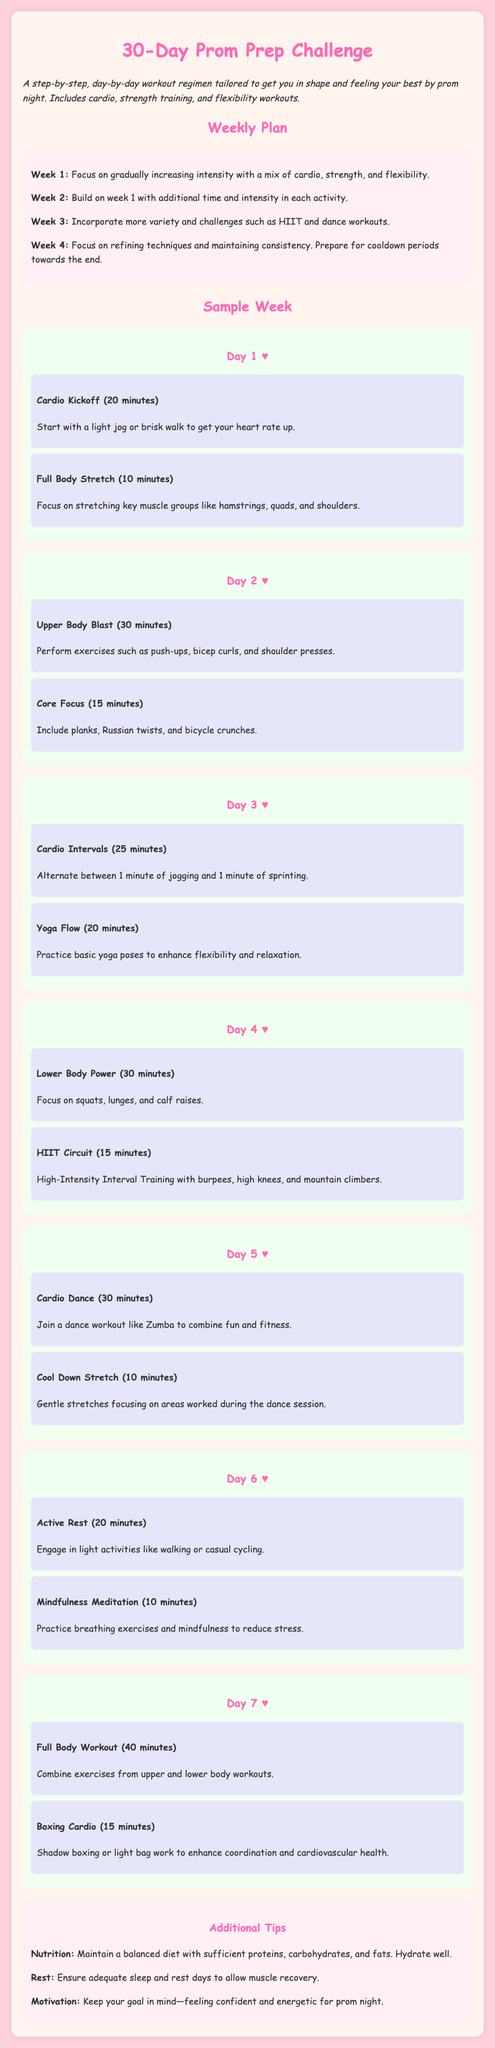What is the duration of cardio on Day 1? The document states that the cardio kickoff on Day 1 is for 20 minutes.
Answer: 20 minutes How many activities are listed for Day 5? There are two activities listed for Day 5: one cardio dance and one cool-down stretch.
Answer: 2 What type of workout is scheduled for Day 3? The document mentions that Day 3 includes cardio intervals and a yoga flow.
Answer: Cardio intervals and yoga flow What is the focus of Week 2? Week 2 builds on the previous week with additional time and intensity in each activity.
Answer: Additional time and intensity What type of training is emphasized in Week 4? The focus in Week 4 is on refining techniques and maintaining consistency.
Answer: Refining techniques and maintaining consistency How long is the active rest on Day 6? The active rest on Day 6 lasts for 20 minutes.
Answer: 20 minutes What exercise is included in the HIIT circuit on Day 4? The HIIT circuit on Day 4 includes burpees, high knees, and mountain climbers.
Answer: Burpees, high knees, mountain climbers What is a recommended additional tip regarding nutrition? The document advises maintaining a balanced diet with sufficient proteins, carbohydrates, and fats.
Answer: Balanced diet with proteins, carbohydrates, and fats 